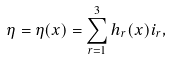Convert formula to latex. <formula><loc_0><loc_0><loc_500><loc_500>\eta = \eta ( x ) = \sum _ { r = 1 } ^ { 3 } h _ { r } ( x ) i _ { r } ,</formula> 